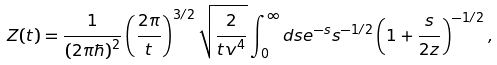<formula> <loc_0><loc_0><loc_500><loc_500>Z ( t ) = { \frac { 1 } { ( 2 \pi \hbar { ) } ^ { 2 } } } \left ( { \frac { 2 \pi } { t } } \right ) ^ { 3 / 2 } \sqrt { { \frac { 2 } { t v ^ { 4 } } } } \int _ { 0 } ^ { \infty } d s e ^ { - s } s ^ { - 1 / 2 } \left ( 1 + { \frac { s } { 2 z } } \right ) ^ { - 1 / 2 } ,</formula> 